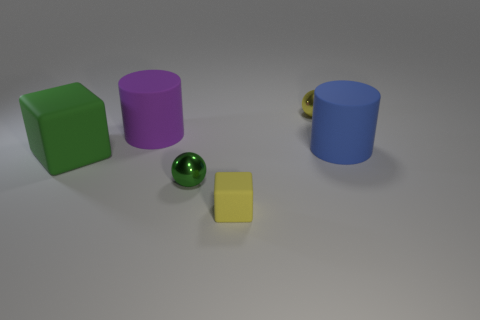What colors are present in the objects shown? The image features objects in green, purple, blue, and yellow. Additionally, there is a small object with gold and black coloring. How many objects are there, and can you describe their shapes? There are five objects in total. Starting from the left, there's a green cube, a purple cylinder, a small green sphere, a yellow cube smaller than the first, and a blue cylinder that's identical in shape to the purple one but varies in size and color. 